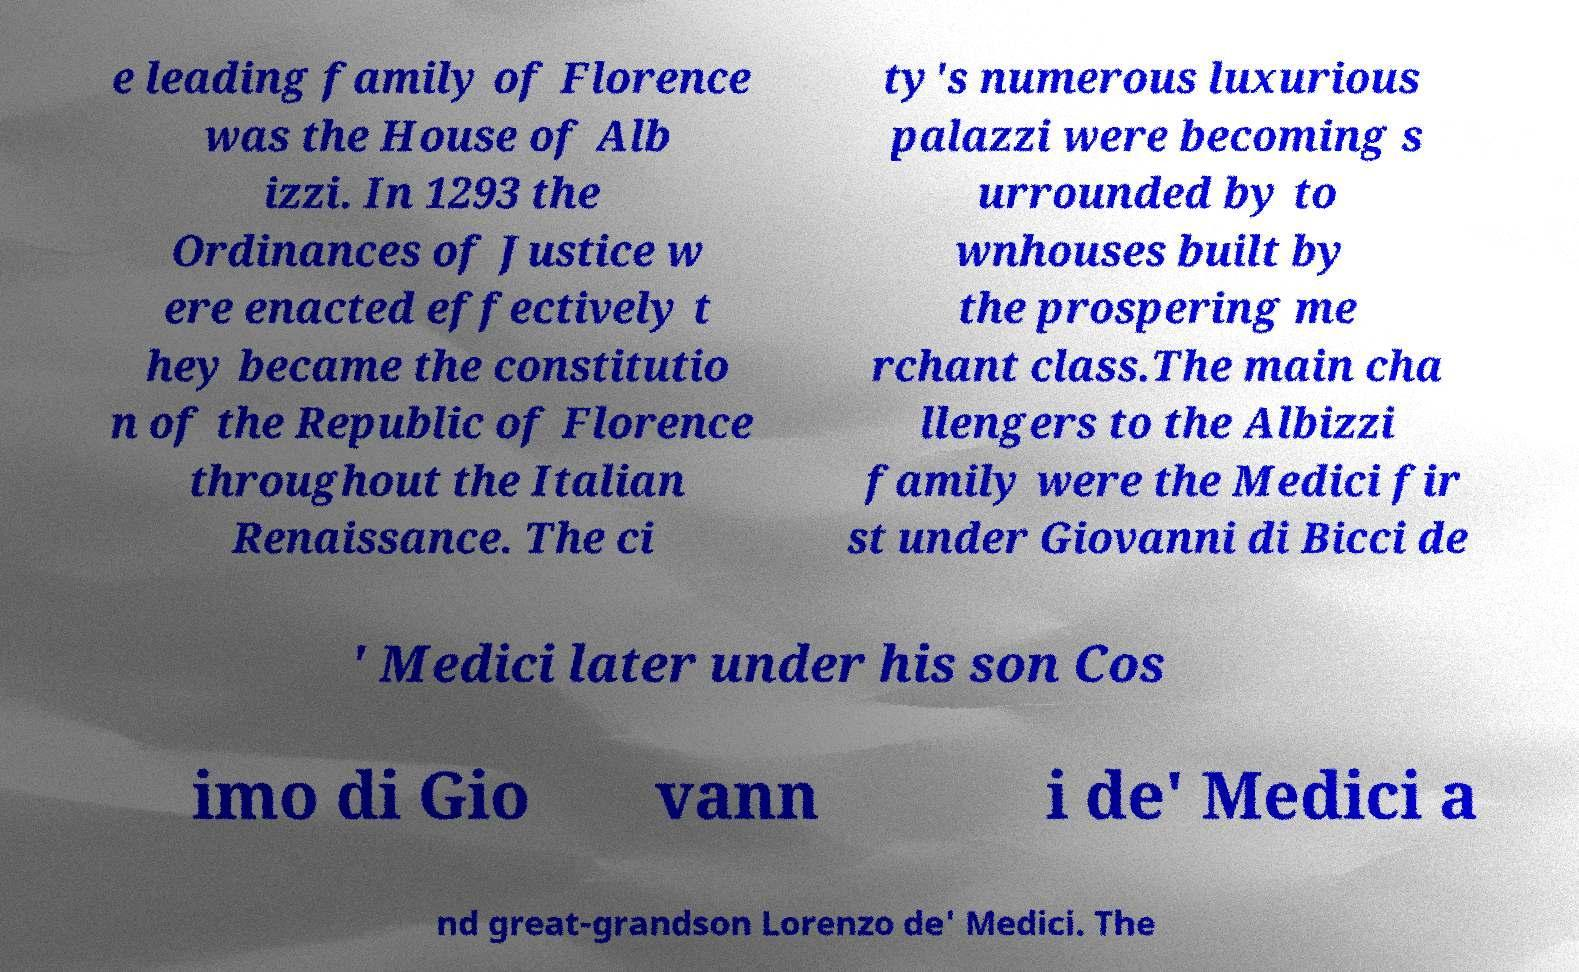Can you read and provide the text displayed in the image?This photo seems to have some interesting text. Can you extract and type it out for me? e leading family of Florence was the House of Alb izzi. In 1293 the Ordinances of Justice w ere enacted effectively t hey became the constitutio n of the Republic of Florence throughout the Italian Renaissance. The ci ty's numerous luxurious palazzi were becoming s urrounded by to wnhouses built by the prospering me rchant class.The main cha llengers to the Albizzi family were the Medici fir st under Giovanni di Bicci de ' Medici later under his son Cos imo di Gio vann i de' Medici a nd great-grandson Lorenzo de' Medici. The 